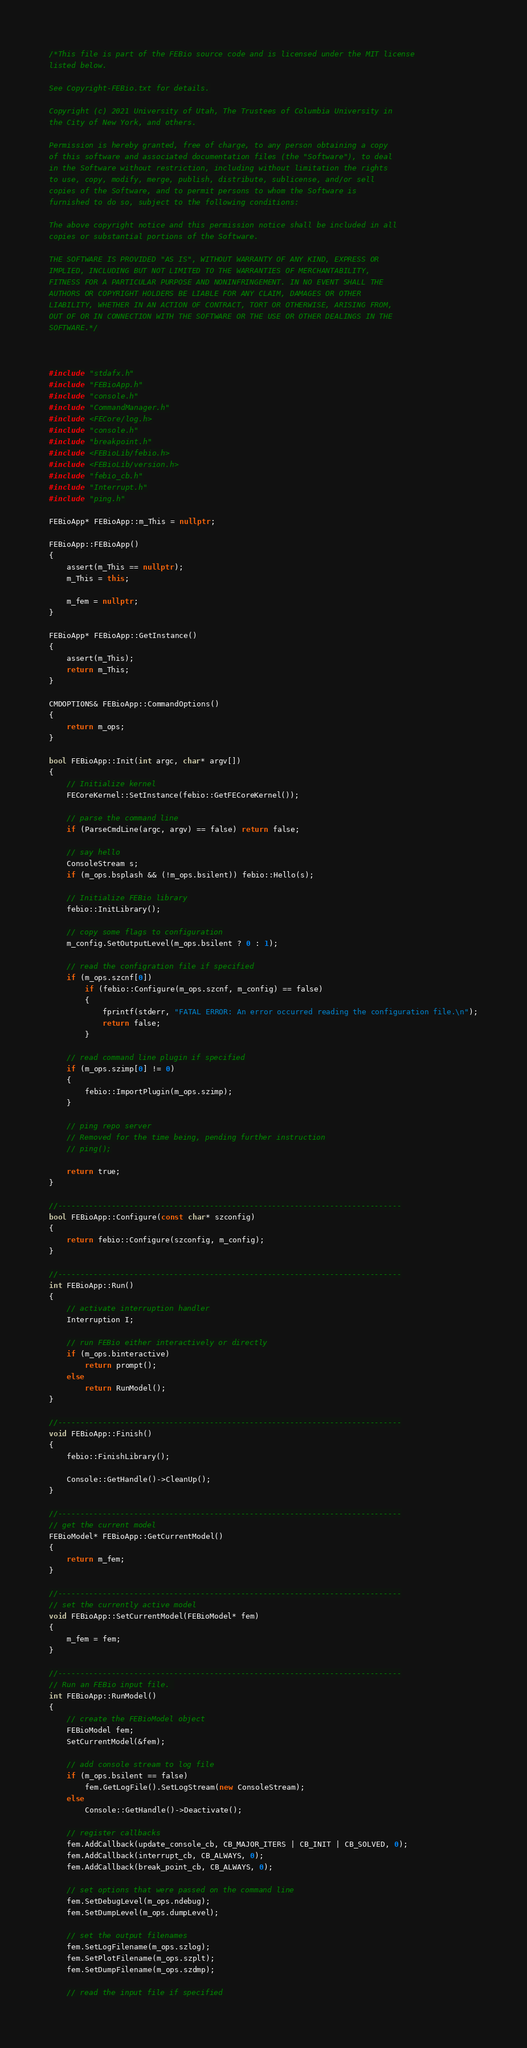<code> <loc_0><loc_0><loc_500><loc_500><_C++_>/*This file is part of the FEBio source code and is licensed under the MIT license
listed below.

See Copyright-FEBio.txt for details.

Copyright (c) 2021 University of Utah, The Trustees of Columbia University in
the City of New York, and others.

Permission is hereby granted, free of charge, to any person obtaining a copy
of this software and associated documentation files (the "Software"), to deal
in the Software without restriction, including without limitation the rights
to use, copy, modify, merge, publish, distribute, sublicense, and/or sell
copies of the Software, and to permit persons to whom the Software is
furnished to do so, subject to the following conditions:

The above copyright notice and this permission notice shall be included in all
copies or substantial portions of the Software.

THE SOFTWARE IS PROVIDED "AS IS", WITHOUT WARRANTY OF ANY KIND, EXPRESS OR
IMPLIED, INCLUDING BUT NOT LIMITED TO THE WARRANTIES OF MERCHANTABILITY,
FITNESS FOR A PARTICULAR PURPOSE AND NONINFRINGEMENT. IN NO EVENT SHALL THE
AUTHORS OR COPYRIGHT HOLDERS BE LIABLE FOR ANY CLAIM, DAMAGES OR OTHER
LIABILITY, WHETHER IN AN ACTION OF CONTRACT, TORT OR OTHERWISE, ARISING FROM,
OUT OF OR IN CONNECTION WITH THE SOFTWARE OR THE USE OR OTHER DEALINGS IN THE
SOFTWARE.*/



#include "stdafx.h"
#include "FEBioApp.h"
#include "console.h"
#include "CommandManager.h"
#include <FECore/log.h>
#include "console.h"
#include "breakpoint.h"
#include <FEBioLib/febio.h>
#include <FEBioLib/version.h>
#include "febio_cb.h"
#include "Interrupt.h"
#include "ping.h"

FEBioApp* FEBioApp::m_This = nullptr;

FEBioApp::FEBioApp()
{
	assert(m_This == nullptr);
	m_This = this;

	m_fem = nullptr;
}

FEBioApp* FEBioApp::GetInstance()
{
	assert(m_This);
	return m_This;
}

CMDOPTIONS& FEBioApp::CommandOptions()
{
	return m_ops;
}

bool FEBioApp::Init(int argc, char* argv[])
{
	// Initialize kernel
	FECoreKernel::SetInstance(febio::GetFECoreKernel());

	// parse the command line
	if (ParseCmdLine(argc, argv) == false) return false;

	// say hello
	ConsoleStream s;
	if (m_ops.bsplash && (!m_ops.bsilent)) febio::Hello(s);

	// Initialize FEBio library
	febio::InitLibrary();

	// copy some flags to configuration
	m_config.SetOutputLevel(m_ops.bsilent ? 0 : 1);

	// read the configration file if specified
	if (m_ops.szcnf[0])
		if (febio::Configure(m_ops.szcnf, m_config) == false)
		{
			fprintf(stderr, "FATAL ERROR: An error occurred reading the configuration file.\n");
			return false;
		}

	// read command line plugin if specified
	if (m_ops.szimp[0] != 0)
	{
		febio::ImportPlugin(m_ops.szimp);
	}

	// ping repo server
	// Removed for the time being, pending further instruction
	// ping();

	return true;
}

//-----------------------------------------------------------------------------
bool FEBioApp::Configure(const char* szconfig)
{
	return febio::Configure(szconfig, m_config);
}

//-----------------------------------------------------------------------------
int FEBioApp::Run()
{
	// activate interruption handler
	Interruption I;

	// run FEBio either interactively or directly
	if (m_ops.binteractive)
		return prompt();
	else
		return RunModel();
}

//-----------------------------------------------------------------------------
void FEBioApp::Finish()
{
	febio::FinishLibrary();

	Console::GetHandle()->CleanUp();
}

//-----------------------------------------------------------------------------
// get the current model
FEBioModel* FEBioApp::GetCurrentModel()
{
	return m_fem;
}

//-----------------------------------------------------------------------------
// set the currently active model
void FEBioApp::SetCurrentModel(FEBioModel* fem)
{
	m_fem = fem;
}

//-----------------------------------------------------------------------------
// Run an FEBio input file. 
int FEBioApp::RunModel()
{
	// create the FEBioModel object
	FEBioModel fem;
	SetCurrentModel(&fem);

	// add console stream to log file
	if (m_ops.bsilent == false)
		fem.GetLogFile().SetLogStream(new ConsoleStream);
	else
		Console::GetHandle()->Deactivate();

	// register callbacks
	fem.AddCallback(update_console_cb, CB_MAJOR_ITERS | CB_INIT | CB_SOLVED, 0);
	fem.AddCallback(interrupt_cb, CB_ALWAYS, 0);
	fem.AddCallback(break_point_cb, CB_ALWAYS, 0);

	// set options that were passed on the command line
	fem.SetDebugLevel(m_ops.ndebug);
	fem.SetDumpLevel(m_ops.dumpLevel);

	// set the output filenames
	fem.SetLogFilename(m_ops.szlog);
	fem.SetPlotFilename(m_ops.szplt);
	fem.SetDumpFilename(m_ops.szdmp);

	// read the input file if specified</code> 